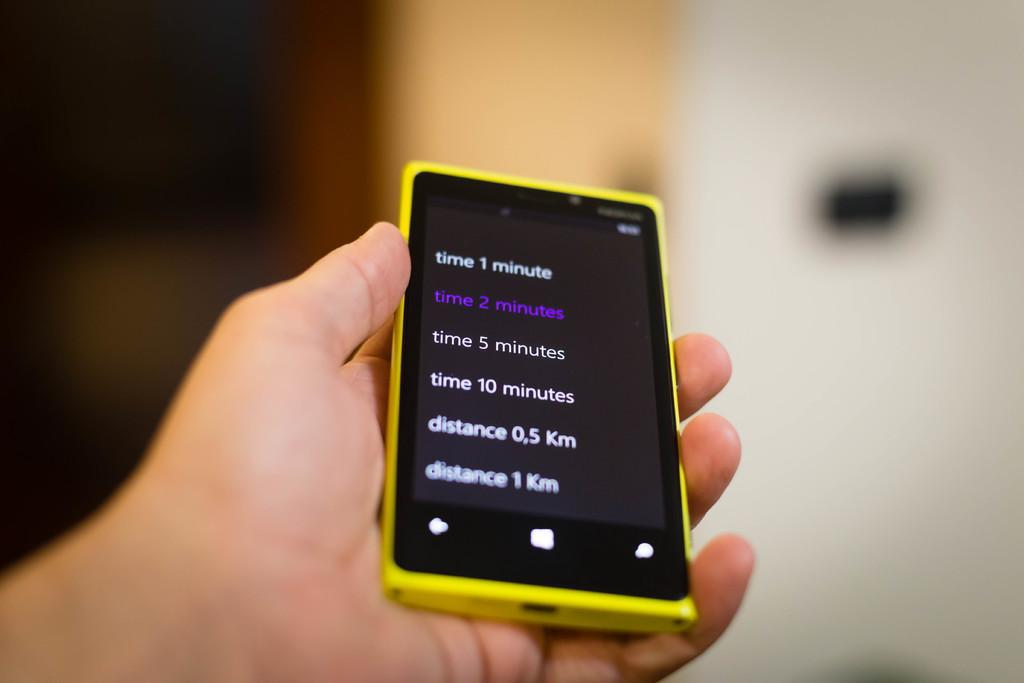<image>
Share a concise interpretation of the image provided. A smarphone with various times and distances on the screen. 